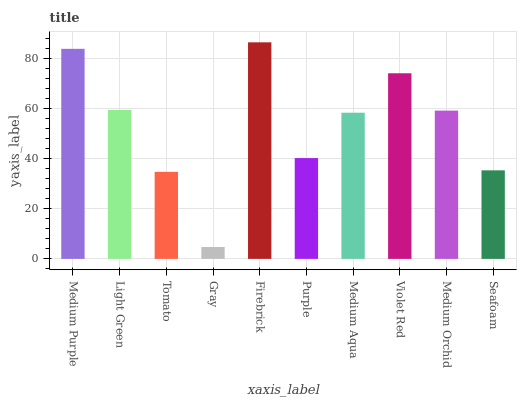Is Gray the minimum?
Answer yes or no. Yes. Is Firebrick the maximum?
Answer yes or no. Yes. Is Light Green the minimum?
Answer yes or no. No. Is Light Green the maximum?
Answer yes or no. No. Is Medium Purple greater than Light Green?
Answer yes or no. Yes. Is Light Green less than Medium Purple?
Answer yes or no. Yes. Is Light Green greater than Medium Purple?
Answer yes or no. No. Is Medium Purple less than Light Green?
Answer yes or no. No. Is Medium Orchid the high median?
Answer yes or no. Yes. Is Medium Aqua the low median?
Answer yes or no. Yes. Is Light Green the high median?
Answer yes or no. No. Is Light Green the low median?
Answer yes or no. No. 